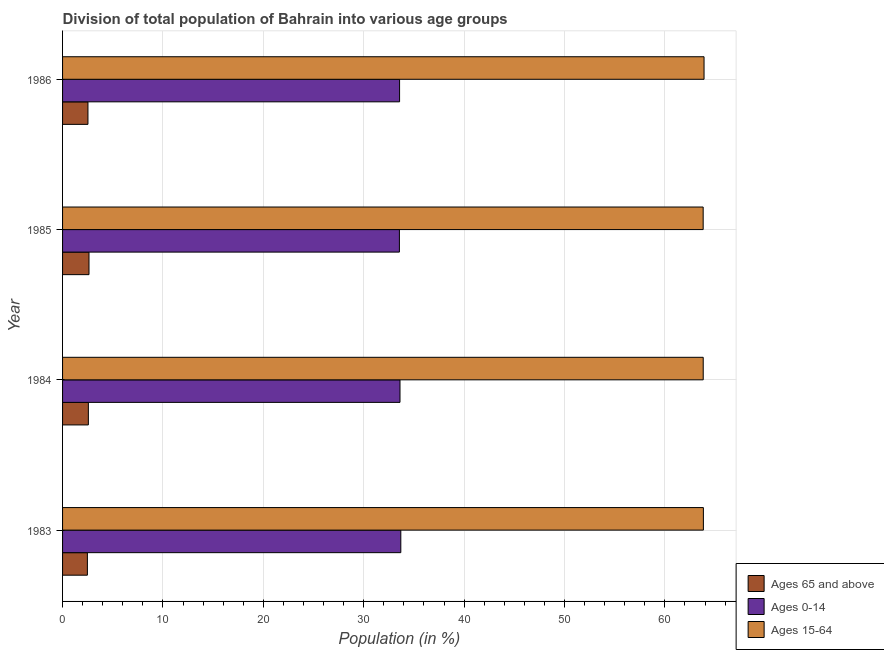How many different coloured bars are there?
Offer a very short reply. 3. How many groups of bars are there?
Your answer should be very brief. 4. How many bars are there on the 3rd tick from the top?
Keep it short and to the point. 3. How many bars are there on the 1st tick from the bottom?
Keep it short and to the point. 3. What is the percentage of population within the age-group 0-14 in 1983?
Provide a short and direct response. 33.69. Across all years, what is the maximum percentage of population within the age-group 0-14?
Your response must be concise. 33.69. Across all years, what is the minimum percentage of population within the age-group of 65 and above?
Your response must be concise. 2.47. What is the total percentage of population within the age-group of 65 and above in the graph?
Make the answer very short. 10.2. What is the difference between the percentage of population within the age-group 0-14 in 1985 and that in 1986?
Give a very brief answer. -0.02. What is the difference between the percentage of population within the age-group 15-64 in 1986 and the percentage of population within the age-group of 65 and above in 1985?
Make the answer very short. 61.27. What is the average percentage of population within the age-group of 65 and above per year?
Your response must be concise. 2.55. In the year 1986, what is the difference between the percentage of population within the age-group 15-64 and percentage of population within the age-group 0-14?
Provide a succinct answer. 30.33. In how many years, is the percentage of population within the age-group of 65 and above greater than 42 %?
Provide a short and direct response. 0. What is the difference between the highest and the second highest percentage of population within the age-group of 65 and above?
Give a very brief answer. 0.06. What is the difference between the highest and the lowest percentage of population within the age-group 15-64?
Provide a short and direct response. 0.09. In how many years, is the percentage of population within the age-group 15-64 greater than the average percentage of population within the age-group 15-64 taken over all years?
Your response must be concise. 1. What does the 3rd bar from the top in 1985 represents?
Give a very brief answer. Ages 65 and above. What does the 1st bar from the bottom in 1984 represents?
Make the answer very short. Ages 65 and above. Is it the case that in every year, the sum of the percentage of population within the age-group of 65 and above and percentage of population within the age-group 0-14 is greater than the percentage of population within the age-group 15-64?
Keep it short and to the point. No. Are all the bars in the graph horizontal?
Offer a very short reply. Yes. How many legend labels are there?
Give a very brief answer. 3. How are the legend labels stacked?
Make the answer very short. Vertical. What is the title of the graph?
Provide a short and direct response. Division of total population of Bahrain into various age groups
. What is the label or title of the Y-axis?
Keep it short and to the point. Year. What is the Population (in %) of Ages 65 and above in 1983?
Provide a succinct answer. 2.47. What is the Population (in %) in Ages 0-14 in 1983?
Offer a very short reply. 33.69. What is the Population (in %) in Ages 15-64 in 1983?
Your response must be concise. 63.83. What is the Population (in %) in Ages 65 and above in 1984?
Give a very brief answer. 2.57. What is the Population (in %) of Ages 0-14 in 1984?
Offer a terse response. 33.61. What is the Population (in %) of Ages 15-64 in 1984?
Make the answer very short. 63.82. What is the Population (in %) in Ages 65 and above in 1985?
Provide a succinct answer. 2.63. What is the Population (in %) of Ages 0-14 in 1985?
Your response must be concise. 33.55. What is the Population (in %) in Ages 15-64 in 1985?
Ensure brevity in your answer.  63.81. What is the Population (in %) of Ages 65 and above in 1986?
Make the answer very short. 2.53. What is the Population (in %) in Ages 0-14 in 1986?
Keep it short and to the point. 33.57. What is the Population (in %) of Ages 15-64 in 1986?
Make the answer very short. 63.9. Across all years, what is the maximum Population (in %) in Ages 65 and above?
Keep it short and to the point. 2.63. Across all years, what is the maximum Population (in %) in Ages 0-14?
Provide a short and direct response. 33.69. Across all years, what is the maximum Population (in %) of Ages 15-64?
Make the answer very short. 63.9. Across all years, what is the minimum Population (in %) of Ages 65 and above?
Offer a terse response. 2.47. Across all years, what is the minimum Population (in %) in Ages 0-14?
Keep it short and to the point. 33.55. Across all years, what is the minimum Population (in %) of Ages 15-64?
Keep it short and to the point. 63.81. What is the total Population (in %) in Ages 65 and above in the graph?
Your answer should be compact. 10.2. What is the total Population (in %) in Ages 0-14 in the graph?
Provide a succinct answer. 134.43. What is the total Population (in %) in Ages 15-64 in the graph?
Ensure brevity in your answer.  255.36. What is the difference between the Population (in %) in Ages 65 and above in 1983 and that in 1984?
Make the answer very short. -0.1. What is the difference between the Population (in %) in Ages 0-14 in 1983 and that in 1984?
Offer a very short reply. 0.08. What is the difference between the Population (in %) of Ages 15-64 in 1983 and that in 1984?
Give a very brief answer. 0.02. What is the difference between the Population (in %) of Ages 65 and above in 1983 and that in 1985?
Offer a terse response. -0.16. What is the difference between the Population (in %) of Ages 0-14 in 1983 and that in 1985?
Offer a terse response. 0.14. What is the difference between the Population (in %) of Ages 15-64 in 1983 and that in 1985?
Ensure brevity in your answer.  0.02. What is the difference between the Population (in %) of Ages 65 and above in 1983 and that in 1986?
Give a very brief answer. -0.06. What is the difference between the Population (in %) of Ages 0-14 in 1983 and that in 1986?
Make the answer very short. 0.12. What is the difference between the Population (in %) in Ages 15-64 in 1983 and that in 1986?
Make the answer very short. -0.07. What is the difference between the Population (in %) in Ages 65 and above in 1984 and that in 1985?
Your response must be concise. -0.06. What is the difference between the Population (in %) of Ages 0-14 in 1984 and that in 1985?
Offer a terse response. 0.06. What is the difference between the Population (in %) of Ages 15-64 in 1984 and that in 1985?
Make the answer very short. 0. What is the difference between the Population (in %) of Ages 65 and above in 1984 and that in 1986?
Offer a terse response. 0.04. What is the difference between the Population (in %) in Ages 0-14 in 1984 and that in 1986?
Provide a succinct answer. 0.04. What is the difference between the Population (in %) in Ages 15-64 in 1984 and that in 1986?
Provide a succinct answer. -0.08. What is the difference between the Population (in %) of Ages 65 and above in 1985 and that in 1986?
Your response must be concise. 0.1. What is the difference between the Population (in %) in Ages 0-14 in 1985 and that in 1986?
Give a very brief answer. -0.02. What is the difference between the Population (in %) in Ages 15-64 in 1985 and that in 1986?
Your answer should be very brief. -0.09. What is the difference between the Population (in %) of Ages 65 and above in 1983 and the Population (in %) of Ages 0-14 in 1984?
Provide a succinct answer. -31.14. What is the difference between the Population (in %) of Ages 65 and above in 1983 and the Population (in %) of Ages 15-64 in 1984?
Make the answer very short. -61.34. What is the difference between the Population (in %) of Ages 0-14 in 1983 and the Population (in %) of Ages 15-64 in 1984?
Keep it short and to the point. -30.12. What is the difference between the Population (in %) in Ages 65 and above in 1983 and the Population (in %) in Ages 0-14 in 1985?
Provide a succinct answer. -31.08. What is the difference between the Population (in %) in Ages 65 and above in 1983 and the Population (in %) in Ages 15-64 in 1985?
Provide a succinct answer. -61.34. What is the difference between the Population (in %) in Ages 0-14 in 1983 and the Population (in %) in Ages 15-64 in 1985?
Keep it short and to the point. -30.12. What is the difference between the Population (in %) in Ages 65 and above in 1983 and the Population (in %) in Ages 0-14 in 1986?
Keep it short and to the point. -31.1. What is the difference between the Population (in %) in Ages 65 and above in 1983 and the Population (in %) in Ages 15-64 in 1986?
Provide a short and direct response. -61.43. What is the difference between the Population (in %) in Ages 0-14 in 1983 and the Population (in %) in Ages 15-64 in 1986?
Ensure brevity in your answer.  -30.21. What is the difference between the Population (in %) in Ages 65 and above in 1984 and the Population (in %) in Ages 0-14 in 1985?
Provide a succinct answer. -30.98. What is the difference between the Population (in %) of Ages 65 and above in 1984 and the Population (in %) of Ages 15-64 in 1985?
Your answer should be compact. -61.24. What is the difference between the Population (in %) of Ages 0-14 in 1984 and the Population (in %) of Ages 15-64 in 1985?
Your answer should be very brief. -30.2. What is the difference between the Population (in %) in Ages 65 and above in 1984 and the Population (in %) in Ages 0-14 in 1986?
Keep it short and to the point. -31. What is the difference between the Population (in %) in Ages 65 and above in 1984 and the Population (in %) in Ages 15-64 in 1986?
Provide a succinct answer. -61.33. What is the difference between the Population (in %) in Ages 0-14 in 1984 and the Population (in %) in Ages 15-64 in 1986?
Your answer should be compact. -30.29. What is the difference between the Population (in %) of Ages 65 and above in 1985 and the Population (in %) of Ages 0-14 in 1986?
Give a very brief answer. -30.94. What is the difference between the Population (in %) of Ages 65 and above in 1985 and the Population (in %) of Ages 15-64 in 1986?
Ensure brevity in your answer.  -61.27. What is the difference between the Population (in %) of Ages 0-14 in 1985 and the Population (in %) of Ages 15-64 in 1986?
Your response must be concise. -30.35. What is the average Population (in %) of Ages 65 and above per year?
Give a very brief answer. 2.55. What is the average Population (in %) in Ages 0-14 per year?
Provide a succinct answer. 33.61. What is the average Population (in %) of Ages 15-64 per year?
Ensure brevity in your answer.  63.84. In the year 1983, what is the difference between the Population (in %) of Ages 65 and above and Population (in %) of Ages 0-14?
Make the answer very short. -31.22. In the year 1983, what is the difference between the Population (in %) of Ages 65 and above and Population (in %) of Ages 15-64?
Give a very brief answer. -61.36. In the year 1983, what is the difference between the Population (in %) in Ages 0-14 and Population (in %) in Ages 15-64?
Ensure brevity in your answer.  -30.14. In the year 1984, what is the difference between the Population (in %) of Ages 65 and above and Population (in %) of Ages 0-14?
Offer a terse response. -31.04. In the year 1984, what is the difference between the Population (in %) of Ages 65 and above and Population (in %) of Ages 15-64?
Your answer should be compact. -61.25. In the year 1984, what is the difference between the Population (in %) in Ages 0-14 and Population (in %) in Ages 15-64?
Your answer should be very brief. -30.2. In the year 1985, what is the difference between the Population (in %) of Ages 65 and above and Population (in %) of Ages 0-14?
Your response must be concise. -30.92. In the year 1985, what is the difference between the Population (in %) in Ages 65 and above and Population (in %) in Ages 15-64?
Give a very brief answer. -61.18. In the year 1985, what is the difference between the Population (in %) of Ages 0-14 and Population (in %) of Ages 15-64?
Provide a short and direct response. -30.26. In the year 1986, what is the difference between the Population (in %) in Ages 65 and above and Population (in %) in Ages 0-14?
Provide a succinct answer. -31.04. In the year 1986, what is the difference between the Population (in %) in Ages 65 and above and Population (in %) in Ages 15-64?
Ensure brevity in your answer.  -61.37. In the year 1986, what is the difference between the Population (in %) in Ages 0-14 and Population (in %) in Ages 15-64?
Keep it short and to the point. -30.33. What is the ratio of the Population (in %) in Ages 65 and above in 1983 to that in 1984?
Make the answer very short. 0.96. What is the ratio of the Population (in %) of Ages 0-14 in 1983 to that in 1984?
Offer a terse response. 1. What is the ratio of the Population (in %) in Ages 15-64 in 1983 to that in 1984?
Give a very brief answer. 1. What is the ratio of the Population (in %) of Ages 65 and above in 1983 to that in 1985?
Make the answer very short. 0.94. What is the ratio of the Population (in %) in Ages 15-64 in 1983 to that in 1985?
Your answer should be compact. 1. What is the ratio of the Population (in %) of Ages 65 and above in 1983 to that in 1986?
Your response must be concise. 0.98. What is the ratio of the Population (in %) of Ages 65 and above in 1984 to that in 1985?
Your answer should be compact. 0.98. What is the ratio of the Population (in %) of Ages 15-64 in 1984 to that in 1985?
Your answer should be very brief. 1. What is the ratio of the Population (in %) of Ages 65 and above in 1984 to that in 1986?
Offer a very short reply. 1.02. What is the ratio of the Population (in %) of Ages 0-14 in 1984 to that in 1986?
Provide a succinct answer. 1. What is the ratio of the Population (in %) in Ages 65 and above in 1985 to that in 1986?
Provide a short and direct response. 1.04. What is the ratio of the Population (in %) of Ages 0-14 in 1985 to that in 1986?
Provide a short and direct response. 1. What is the ratio of the Population (in %) in Ages 15-64 in 1985 to that in 1986?
Offer a very short reply. 1. What is the difference between the highest and the second highest Population (in %) in Ages 65 and above?
Offer a terse response. 0.06. What is the difference between the highest and the second highest Population (in %) in Ages 0-14?
Your answer should be compact. 0.08. What is the difference between the highest and the second highest Population (in %) of Ages 15-64?
Make the answer very short. 0.07. What is the difference between the highest and the lowest Population (in %) in Ages 65 and above?
Your answer should be very brief. 0.16. What is the difference between the highest and the lowest Population (in %) in Ages 0-14?
Your response must be concise. 0.14. What is the difference between the highest and the lowest Population (in %) in Ages 15-64?
Keep it short and to the point. 0.09. 